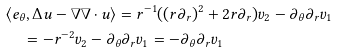<formula> <loc_0><loc_0><loc_500><loc_500>& \langle e _ { \theta } , \Delta u - \nabla \nabla \cdot u \rangle = r ^ { - 1 } ( ( r \partial _ { r } ) ^ { 2 } + 2 r \partial _ { r } ) v _ { 2 } - \partial _ { \theta } \partial _ { r } v _ { 1 } \\ & \quad = - r ^ { - 2 } v _ { 2 } - \partial _ { \theta } \partial _ { r } v _ { 1 } = - \partial _ { \theta } \partial _ { r } v _ { 1 }</formula> 